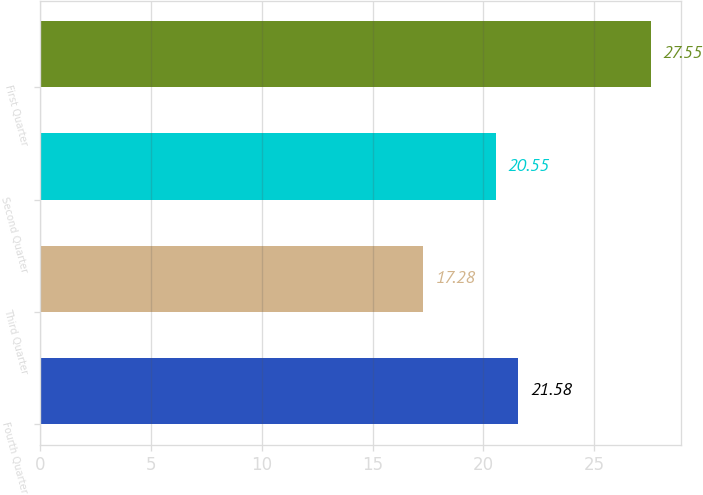Convert chart. <chart><loc_0><loc_0><loc_500><loc_500><bar_chart><fcel>Fourth Quarter<fcel>Third Quarter<fcel>Second Quarter<fcel>First Quarter<nl><fcel>21.58<fcel>17.28<fcel>20.55<fcel>27.55<nl></chart> 